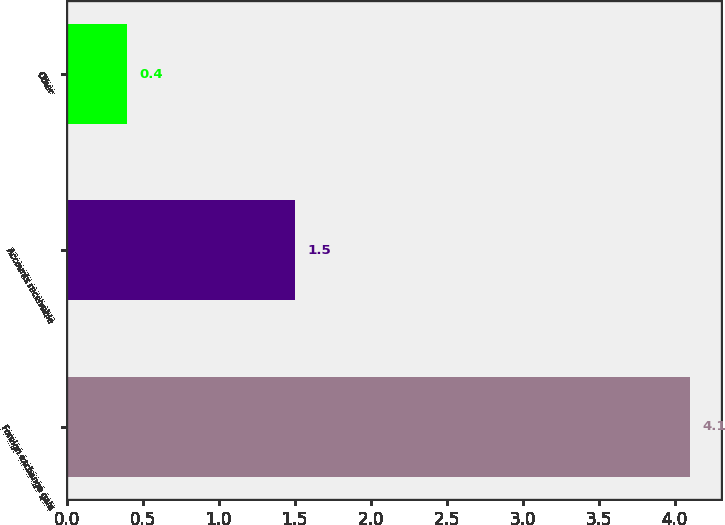Convert chart. <chart><loc_0><loc_0><loc_500><loc_500><bar_chart><fcel>Foreign exchange gain<fcel>Accounts receivable<fcel>Other<nl><fcel>4.1<fcel>1.5<fcel>0.4<nl></chart> 